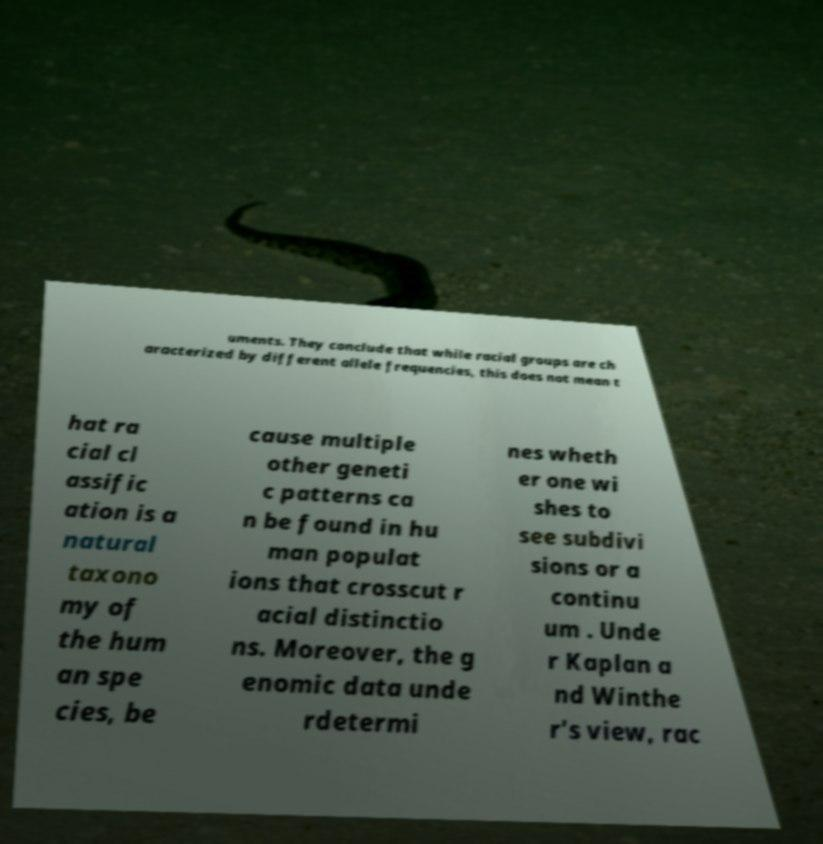Can you accurately transcribe the text from the provided image for me? uments. They conclude that while racial groups are ch aracterized by different allele frequencies, this does not mean t hat ra cial cl assific ation is a natural taxono my of the hum an spe cies, be cause multiple other geneti c patterns ca n be found in hu man populat ions that crosscut r acial distinctio ns. Moreover, the g enomic data unde rdetermi nes wheth er one wi shes to see subdivi sions or a continu um . Unde r Kaplan a nd Winthe r's view, rac 